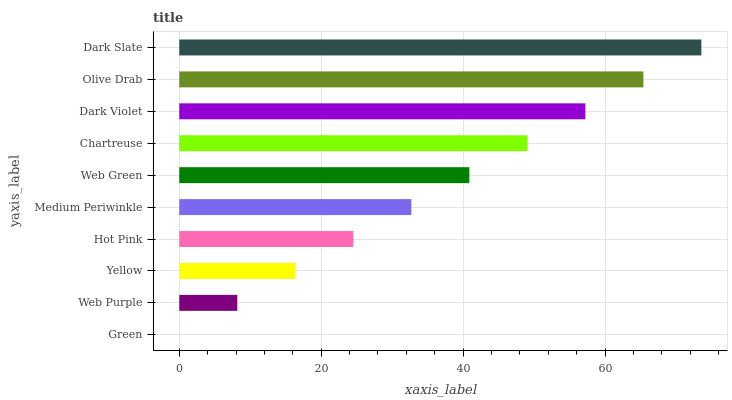Is Green the minimum?
Answer yes or no. Yes. Is Dark Slate the maximum?
Answer yes or no. Yes. Is Web Purple the minimum?
Answer yes or no. No. Is Web Purple the maximum?
Answer yes or no. No. Is Web Purple greater than Green?
Answer yes or no. Yes. Is Green less than Web Purple?
Answer yes or no. Yes. Is Green greater than Web Purple?
Answer yes or no. No. Is Web Purple less than Green?
Answer yes or no. No. Is Web Green the high median?
Answer yes or no. Yes. Is Medium Periwinkle the low median?
Answer yes or no. Yes. Is Dark Slate the high median?
Answer yes or no. No. Is Hot Pink the low median?
Answer yes or no. No. 